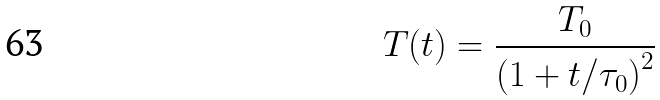Convert formula to latex. <formula><loc_0><loc_0><loc_500><loc_500>T ( t ) = \frac { T _ { 0 } } { \left ( 1 + t / \tau _ { 0 } \right ) ^ { 2 } }</formula> 